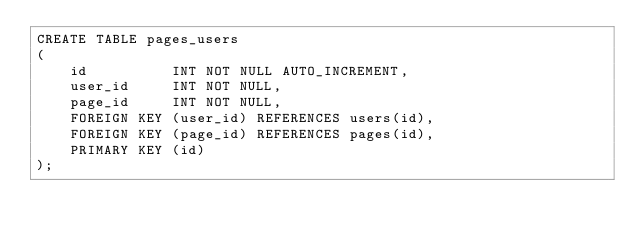Convert code to text. <code><loc_0><loc_0><loc_500><loc_500><_SQL_>CREATE TABLE pages_users
(
    id          INT NOT NULL AUTO_INCREMENT,
    user_id     INT NOT NULL,
    page_id     INT NOT NULL,
    FOREIGN KEY (user_id) REFERENCES users(id),
    FOREIGN KEY (page_id) REFERENCES pages(id),
    PRIMARY KEY (id)
);</code> 